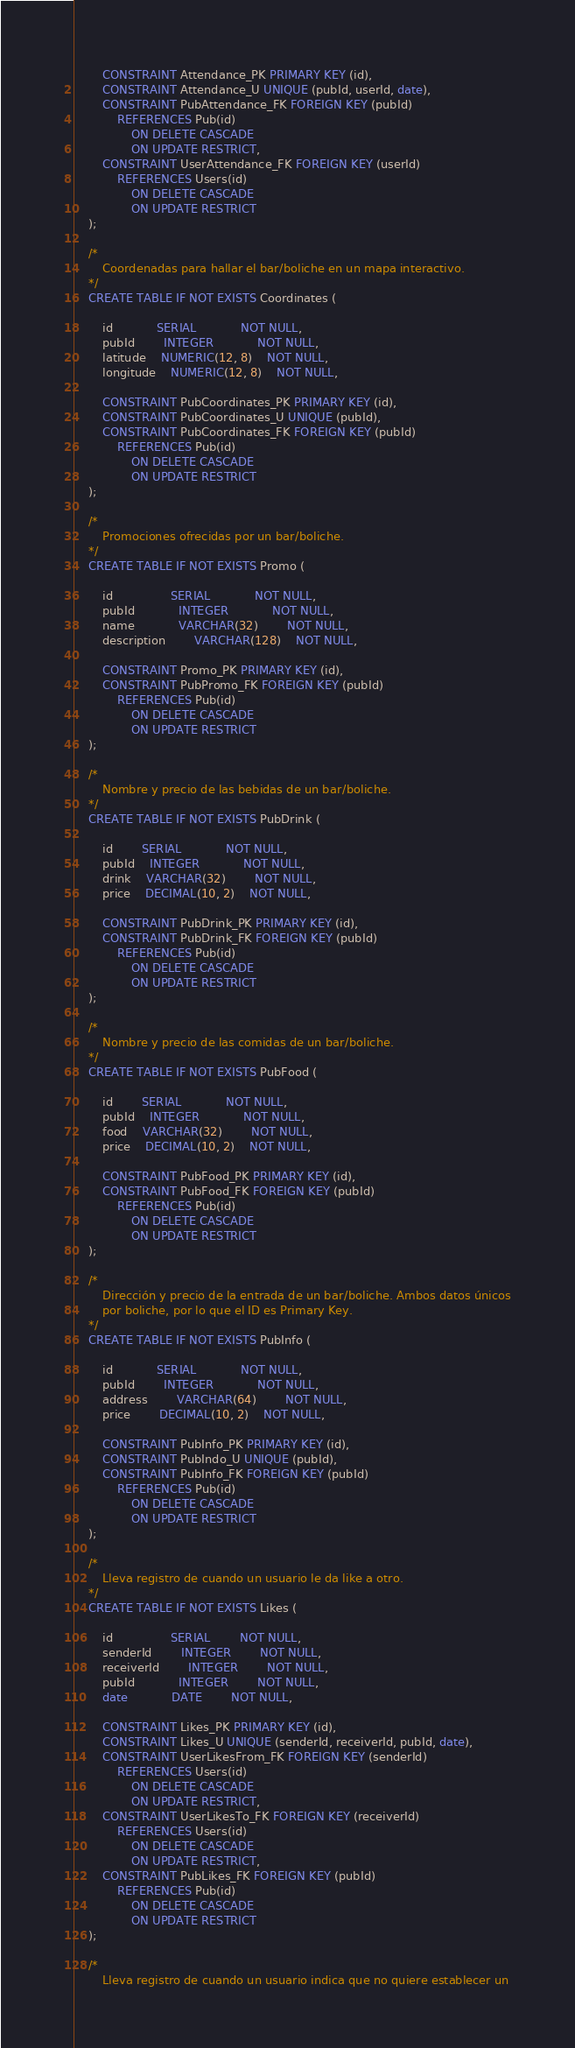<code> <loc_0><loc_0><loc_500><loc_500><_SQL_>		CONSTRAINT Attendance_PK PRIMARY KEY (id),
		CONSTRAINT Attendance_U UNIQUE (pubId, userId, date),
		CONSTRAINT PubAttendance_FK FOREIGN KEY (pubId)
			REFERENCES Pub(id)
				ON DELETE CASCADE
				ON UPDATE RESTRICT,
		CONSTRAINT UserAttendance_FK FOREIGN KEY (userId)
			REFERENCES Users(id)
				ON DELETE CASCADE
				ON UPDATE RESTRICT
	);

	/*
		Coordenadas para hallar el bar/boliche en un mapa interactivo.
	*/
	CREATE TABLE IF NOT EXISTS Coordinates (

		id 			SERIAL 			NOT NULL,
		pubId		INTEGER			NOT NULL,
		latitude	NUMERIC(12, 8)	NOT NULL,
		longitude	NUMERIC(12, 8)	NOT NULL,

		CONSTRAINT PubCoordinates_PK PRIMARY KEY (id),
		CONSTRAINT PubCoordinates_U UNIQUE (pubId),
		CONSTRAINT PubCoordinates_FK FOREIGN KEY (pubId)
			REFERENCES Pub(id)
				ON DELETE CASCADE
				ON UPDATE RESTRICT
	);

	/*
		Promociones ofrecidas por un bar/boliche.
	*/
	CREATE TABLE IF NOT EXISTS Promo (

		id 				SERIAL 			NOT NULL,
		pubId			INTEGER			NOT NULL,
		name			VARCHAR(32)		NOT NULL,
		description		VARCHAR(128)	NOT NULL,

		CONSTRAINT Promo_PK PRIMARY KEY (id),
		CONSTRAINT PubPromo_FK FOREIGN KEY (pubId)
			REFERENCES Pub(id)
				ON DELETE CASCADE
				ON UPDATE RESTRICT
	);

	/*
		Nombre y precio de las bebidas de un bar/boliche.
	*/
	CREATE TABLE IF NOT EXISTS PubDrink (

		id		SERIAL 			NOT NULL,
		pubId	INTEGER			NOT NULL,
		drink	VARCHAR(32)		NOT NULL,
		price	DECIMAL(10, 2)	NOT NULL,

		CONSTRAINT PubDrink_PK PRIMARY KEY (id),
		CONSTRAINT PubDrink_FK FOREIGN KEY (pubId)
			REFERENCES Pub(id)
				ON DELETE CASCADE
				ON UPDATE RESTRICT
	);

	/*
		Nombre y precio de las comidas de un bar/boliche.
	*/
	CREATE TABLE IF NOT EXISTS PubFood (

		id 		SERIAL 			NOT NULL,
		pubId	INTEGER			NOT NULL,
		food	VARCHAR(32)		NOT NULL,
		price	DECIMAL(10, 2)	NOT NULL,

		CONSTRAINT PubFood_PK PRIMARY KEY (id),
		CONSTRAINT PubFood_FK FOREIGN KEY (pubId)
			REFERENCES Pub(id)
				ON DELETE CASCADE
				ON UPDATE RESTRICT
	);

	/*
		Dirección y precio de la entrada de un bar/boliche. Ambos datos únicos
		por boliche, por lo que el ID es Primary Key.
	*/
	CREATE TABLE IF NOT EXISTS PubInfo (

		id			SERIAL 			NOT NULL,
		pubId		INTEGER			NOT NULL,
		address		VARCHAR(64)		NOT NULL,
		price		DECIMAL(10, 2)	NOT NULL,

		CONSTRAINT PubInfo_PK PRIMARY KEY (id),
		CONSTRAINT PubIndo_U UNIQUE (pubId),
		CONSTRAINT PubInfo_FK FOREIGN KEY (pubId)
			REFERENCES Pub(id)
				ON DELETE CASCADE
				ON UPDATE RESTRICT
	);

	/*
		Lleva registro de cuando un usuario le da like a otro.
	*/
	CREATE TABLE IF NOT EXISTS Likes (

		id 				SERIAL 		NOT NULL,
		senderId		INTEGER		NOT NULL,
		receiverId		INTEGER		NOT NULL,
		pubId			INTEGER		NOT NULL,
		date			DATE		NOT NULL,

		CONSTRAINT Likes_PK PRIMARY KEY (id),
		CONSTRAINT Likes_U UNIQUE (senderId, receiverId, pubId, date),
		CONSTRAINT UserLikesFrom_FK FOREIGN KEY (senderId)
			REFERENCES Users(id)
				ON DELETE CASCADE
				ON UPDATE RESTRICT,
		CONSTRAINT UserLikesTo_FK FOREIGN KEY (receiverId)
			REFERENCES Users(id)
				ON DELETE CASCADE
				ON UPDATE RESTRICT,
		CONSTRAINT PubLikes_FK FOREIGN KEY (pubId)
			REFERENCES Pub(id)
				ON DELETE CASCADE
				ON UPDATE RESTRICT
	);

	/*
		Lleva registro de cuando un usuario indica que no quiere establecer un</code> 